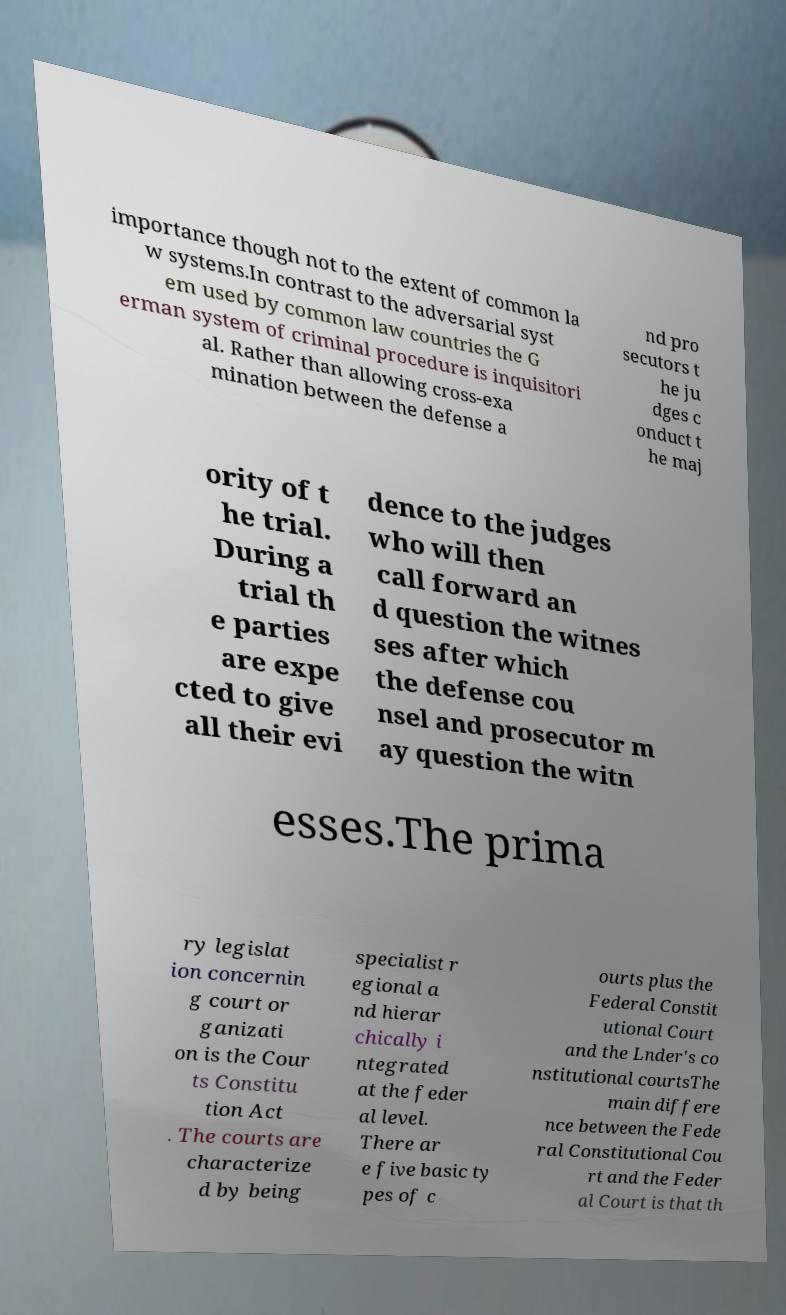Could you extract and type out the text from this image? importance though not to the extent of common la w systems.In contrast to the adversarial syst em used by common law countries the G erman system of criminal procedure is inquisitori al. Rather than allowing cross-exa mination between the defense a nd pro secutors t he ju dges c onduct t he maj ority of t he trial. During a trial th e parties are expe cted to give all their evi dence to the judges who will then call forward an d question the witnes ses after which the defense cou nsel and prosecutor m ay question the witn esses.The prima ry legislat ion concernin g court or ganizati on is the Cour ts Constitu tion Act . The courts are characterize d by being specialist r egional a nd hierar chically i ntegrated at the feder al level. There ar e five basic ty pes of c ourts plus the Federal Constit utional Court and the Lnder's co nstitutional courtsThe main differe nce between the Fede ral Constitutional Cou rt and the Feder al Court is that th 